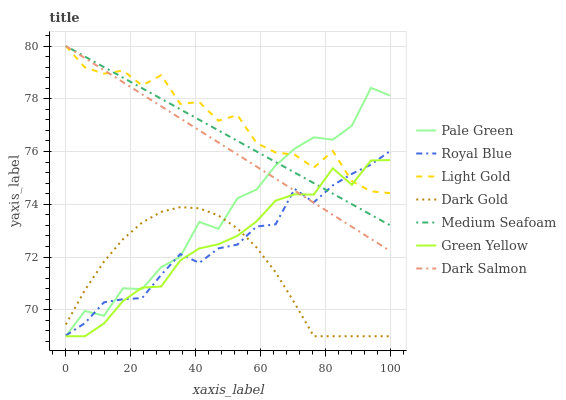Does Dark Salmon have the minimum area under the curve?
Answer yes or no. No. Does Dark Salmon have the maximum area under the curve?
Answer yes or no. No. Is Dark Salmon the smoothest?
Answer yes or no. No. Is Dark Salmon the roughest?
Answer yes or no. No. Does Dark Salmon have the lowest value?
Answer yes or no. No. Does Royal Blue have the highest value?
Answer yes or no. No. Is Dark Gold less than Light Gold?
Answer yes or no. Yes. Is Dark Salmon greater than Dark Gold?
Answer yes or no. Yes. Does Dark Gold intersect Light Gold?
Answer yes or no. No. 